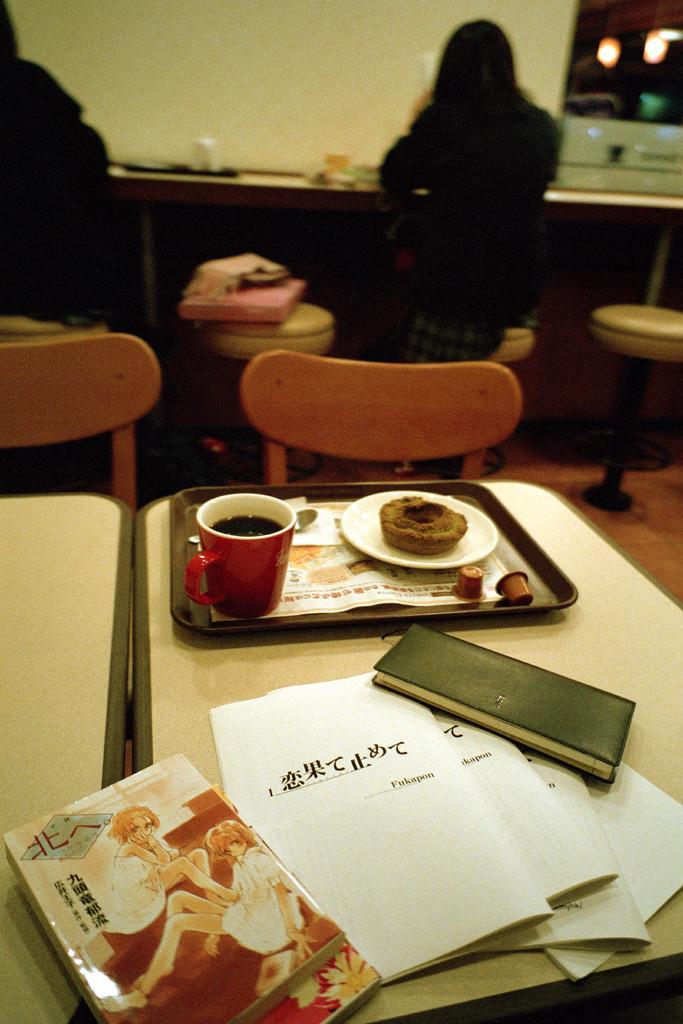Can you describe this image briefly? inside the room there is many chairs and tables are there and two women are sitting on the table on the table there are so many things are there like books,papers and cup,plate and tray. they both women one is watching the book and another woman is doing something. 